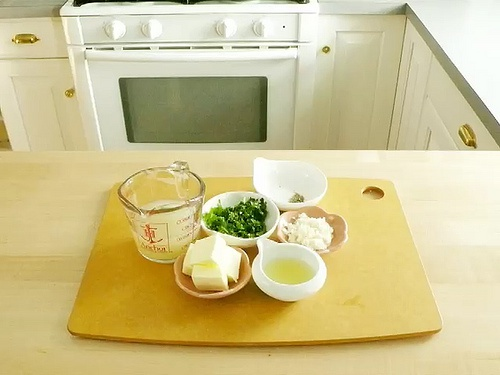Describe the objects in this image and their specific colors. I can see oven in tan, beige, and olive tones, cup in tan and khaki tones, bowl in tan, beige, khaki, and olive tones, bowl in tan, khaki, beige, and olive tones, and bowl in tan, beige, and darkgreen tones in this image. 